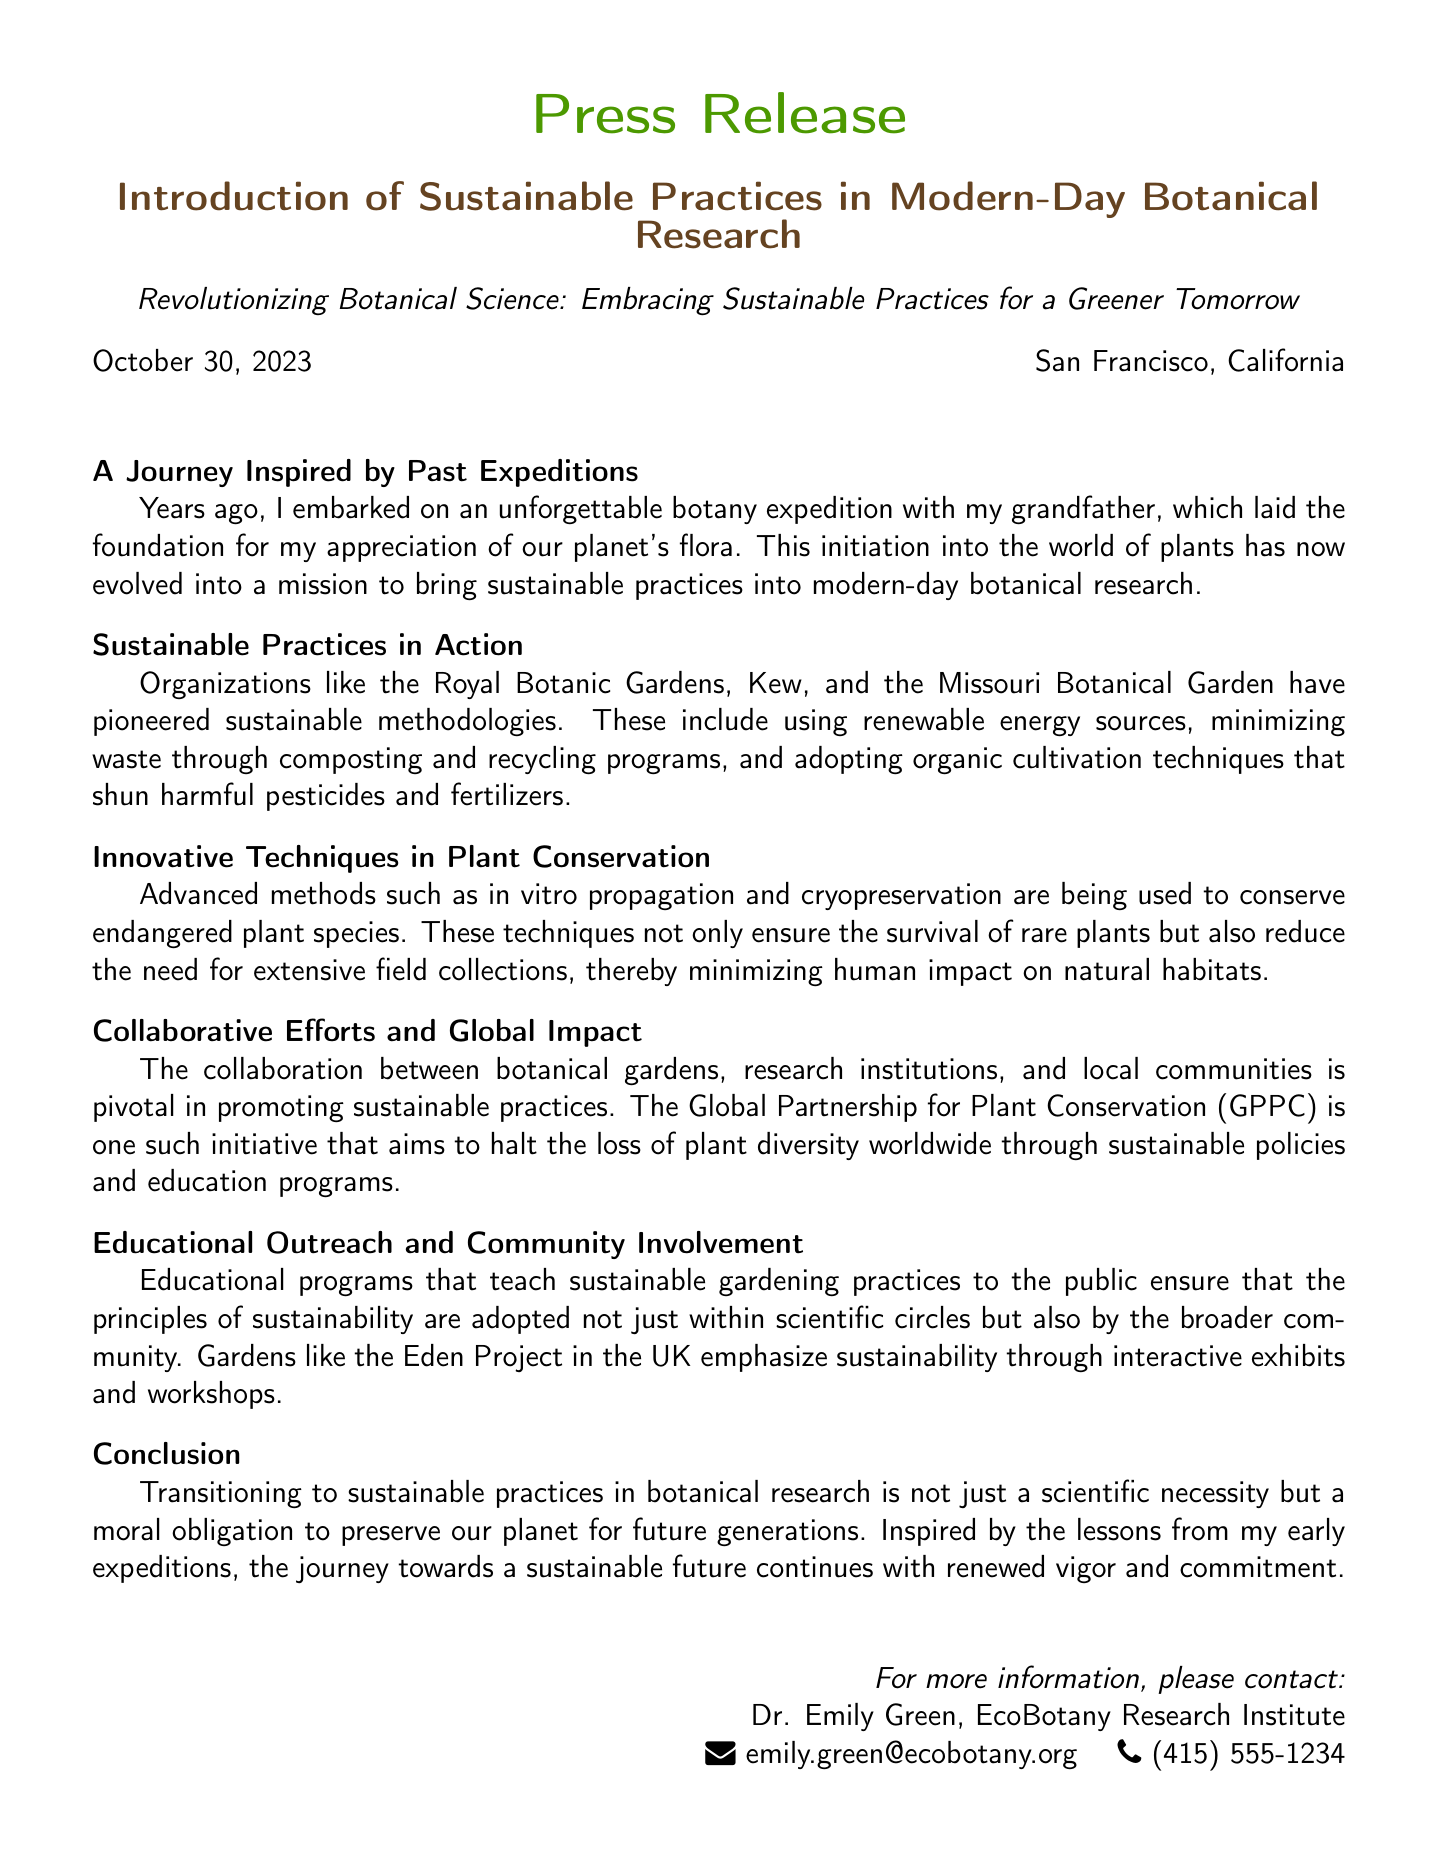What is the title of the press release? The title of the press release is highlighted at the beginning and is meant to capture attention regarding the topic.
Answer: Introduction of Sustainable Practices in Modern-Day Botanical Research Who is the press release intended to contact for more information? The contact person's name is mentioned at the end of the document along with their affiliation and contact details.
Answer: Dr. Emily Green What organization is mentioned as a pioneer in sustainable methodologies? The document explicitly mentions organizations known for their leadership in sustainable practices.
Answer: Royal Botanic Gardens, Kew What date was the press release issued? The date is provided near the top of the document and indicates when the information was made public.
Answer: October 30, 2023 What is the main aim of the Global Partnership for Plant Conservation (GPPC)? The document outlines the objectives of GPPC in relation to plant diversity and conservation efforts.
Answer: Halt the loss of plant diversity worldwide What advanced method is used for conserving endangered plant species? The techniques listed in the document focus on modern approaches to plant conservation.
Answer: In vitro propagation What is emphasized through interactive exhibits at the Eden Project? The press release highlights educational initiatives that promote specific practices to the public.
Answer: Sustainability Why is transitioning to sustainable practices considered a moral obligation? The document argues for the necessity of sustainable practices by referring to ethical considerations regarding the environment.
Answer: Preserve our planet for future generations 